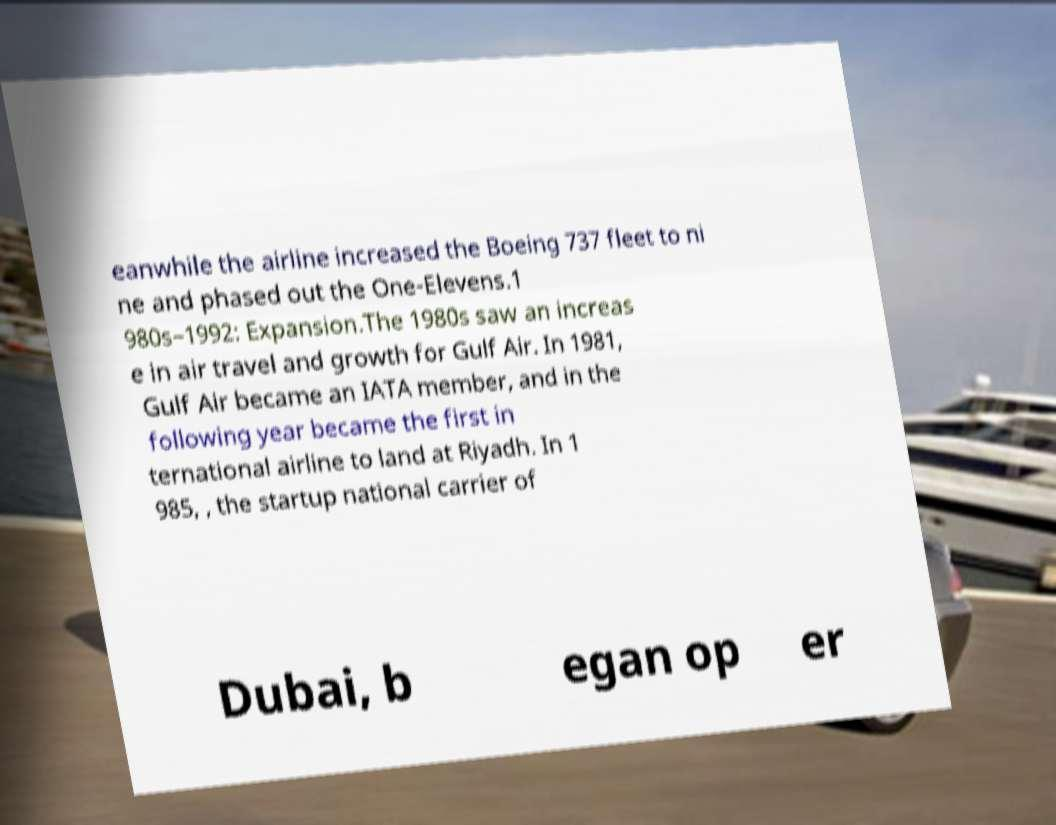Could you assist in decoding the text presented in this image and type it out clearly? eanwhile the airline increased the Boeing 737 fleet to ni ne and phased out the One-Elevens.1 980s–1992: Expansion.The 1980s saw an increas e in air travel and growth for Gulf Air. In 1981, Gulf Air became an IATA member, and in the following year became the first in ternational airline to land at Riyadh. In 1 985, , the startup national carrier of Dubai, b egan op er 